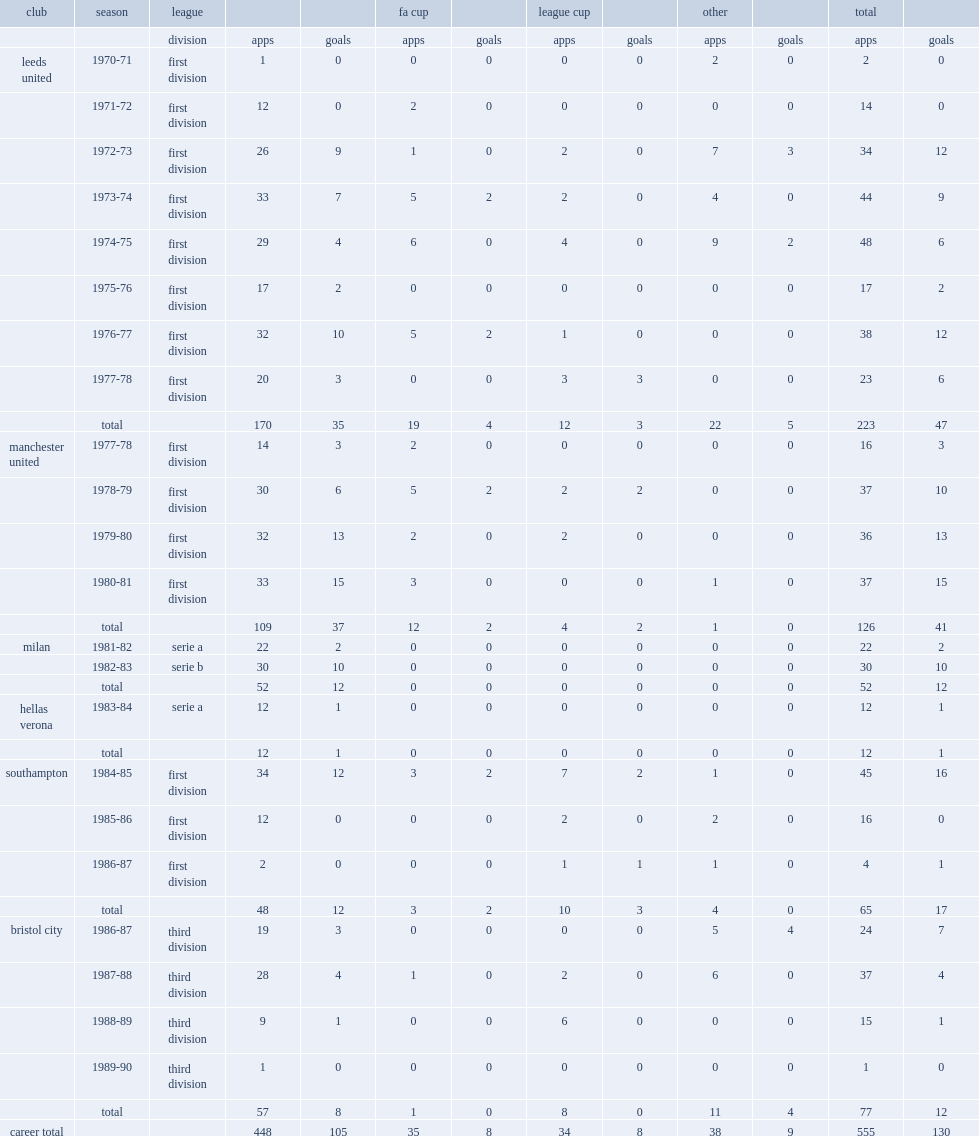Which league was jordan's last season with milan? Serie b. 